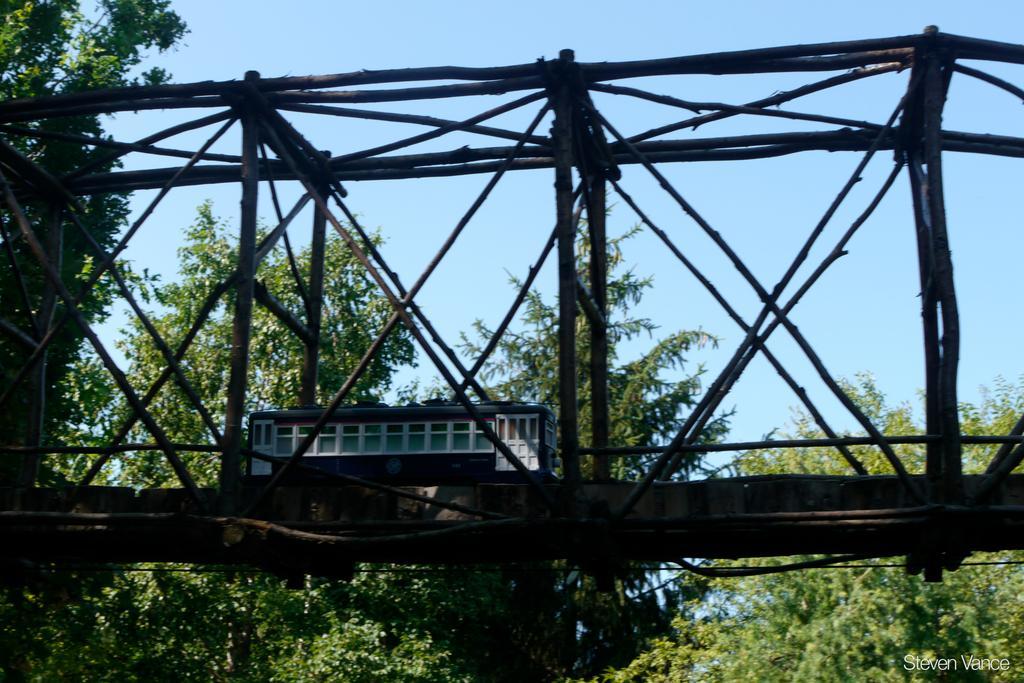Please provide a concise description of this image. In this image I can see a bridge, at back I can see house, and trees in green color and sky in blue color. 